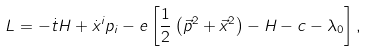<formula> <loc_0><loc_0><loc_500><loc_500>L = - \dot { t } H + \dot { x } ^ { i } p _ { i } - e \left [ \frac { 1 } { 2 } \left ( \vec { p } ^ { 2 } + \vec { x } ^ { 2 } \right ) - H - c - \lambda _ { 0 } \right ] ,</formula> 